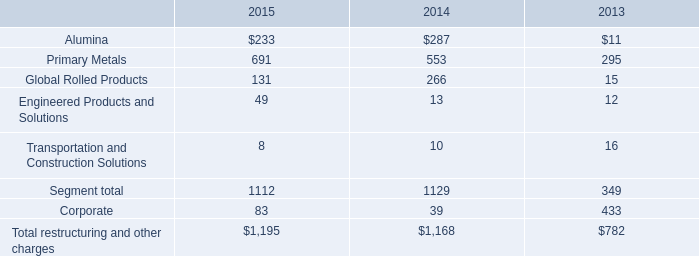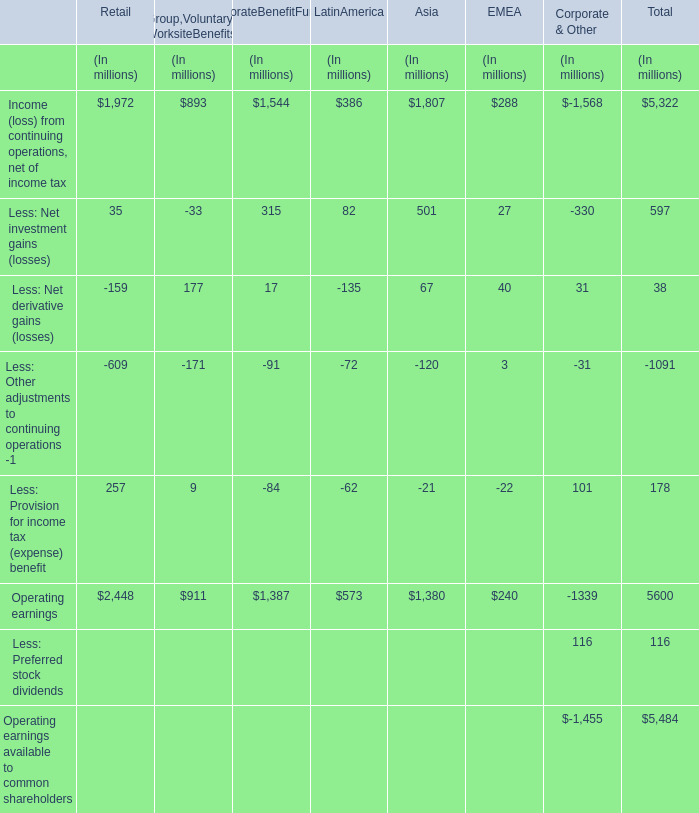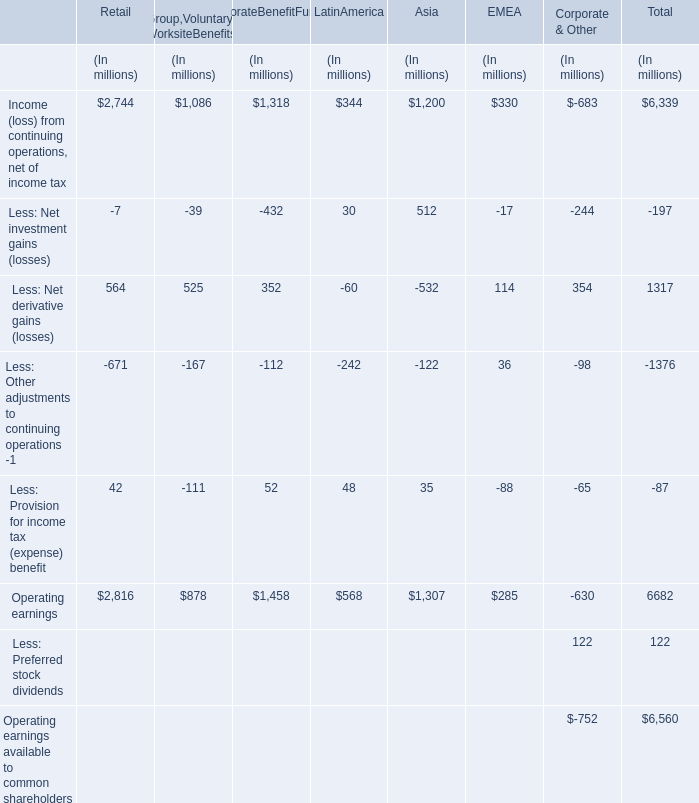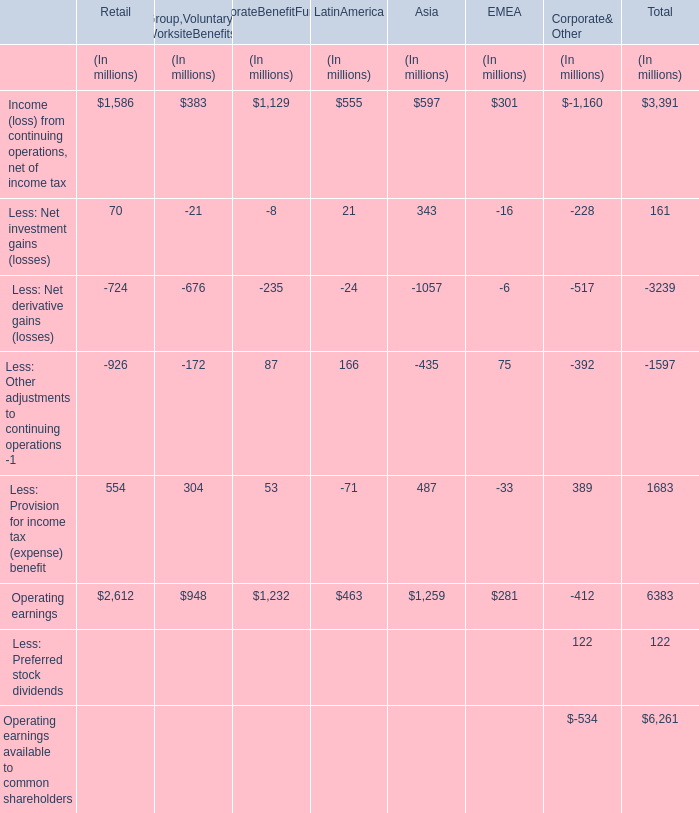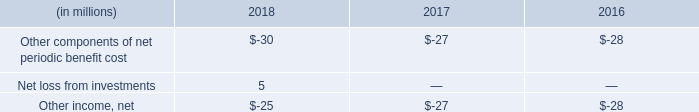What's the greatest value of Operating earnings in all sections except section Total? (in million) 
Answer: 2816. 